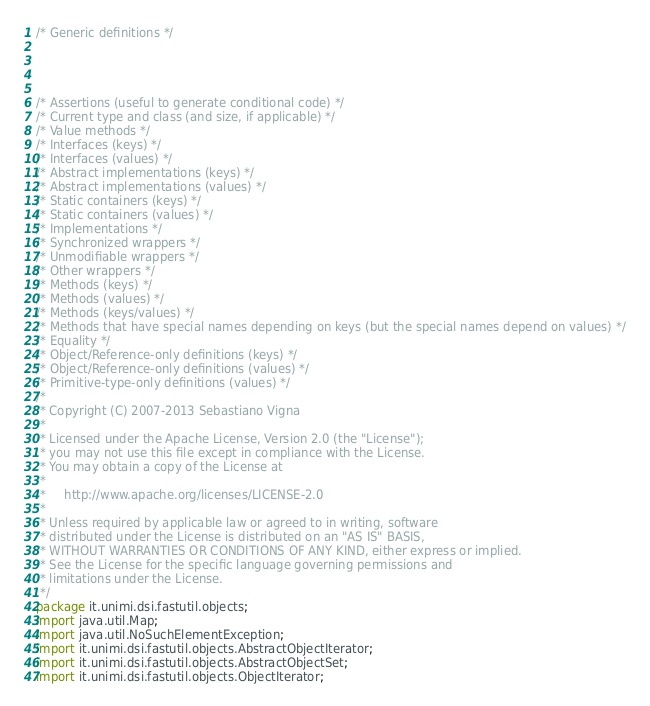Convert code to text. <code><loc_0><loc_0><loc_500><loc_500><_Java_>/* Generic definitions */




/* Assertions (useful to generate conditional code) */
/* Current type and class (and size, if applicable) */
/* Value methods */
/* Interfaces (keys) */
/* Interfaces (values) */
/* Abstract implementations (keys) */
/* Abstract implementations (values) */
/* Static containers (keys) */
/* Static containers (values) */
/* Implementations */
/* Synchronized wrappers */
/* Unmodifiable wrappers */
/* Other wrappers */
/* Methods (keys) */
/* Methods (values) */
/* Methods (keys/values) */
/* Methods that have special names depending on keys (but the special names depend on values) */
/* Equality */
/* Object/Reference-only definitions (keys) */
/* Object/Reference-only definitions (values) */
/* Primitive-type-only definitions (values) */
/*		 
 * Copyright (C) 2007-2013 Sebastiano Vigna 
 *
 * Licensed under the Apache License, Version 2.0 (the "License");
 * you may not use this file except in compliance with the License.
 * You may obtain a copy of the License at
 *
 *     http://www.apache.org/licenses/LICENSE-2.0
 *
 * Unless required by applicable law or agreed to in writing, software
 * distributed under the License is distributed on an "AS IS" BASIS,
 * WITHOUT WARRANTIES OR CONDITIONS OF ANY KIND, either express or implied.
 * See the License for the specific language governing permissions and
 * limitations under the License. 
 */
package it.unimi.dsi.fastutil.objects;
import java.util.Map;
import java.util.NoSuchElementException;
import it.unimi.dsi.fastutil.objects.AbstractObjectIterator;
import it.unimi.dsi.fastutil.objects.AbstractObjectSet;
import it.unimi.dsi.fastutil.objects.ObjectIterator;</code> 